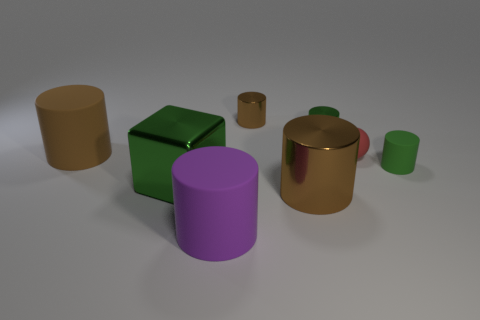Are there any other things that are the same size as the red matte thing?
Make the answer very short. Yes. What is the shape of the green shiny object on the right side of the large brown shiny cylinder?
Your answer should be very brief. Cylinder. There is a rubber thing in front of the large brown cylinder to the right of the tiny shiny thing that is left of the large brown shiny cylinder; how big is it?
Make the answer very short. Large. There is a matte cylinder that is on the right side of the purple matte object; how many green rubber objects are on the left side of it?
Provide a succinct answer. 0. What is the size of the matte cylinder that is behind the big brown metallic cylinder and left of the big brown metallic object?
Keep it short and to the point. Large. How many rubber objects are big things or small purple cylinders?
Keep it short and to the point. 2. What is the material of the red thing?
Give a very brief answer. Rubber. What material is the brown cylinder that is to the left of the small shiny object behind the tiny green cylinder on the left side of the rubber ball?
Your answer should be very brief. Rubber. The brown object that is the same size as the red matte ball is what shape?
Your answer should be compact. Cylinder. What number of things are either small green cylinders or rubber things on the right side of the purple rubber object?
Keep it short and to the point. 3. 